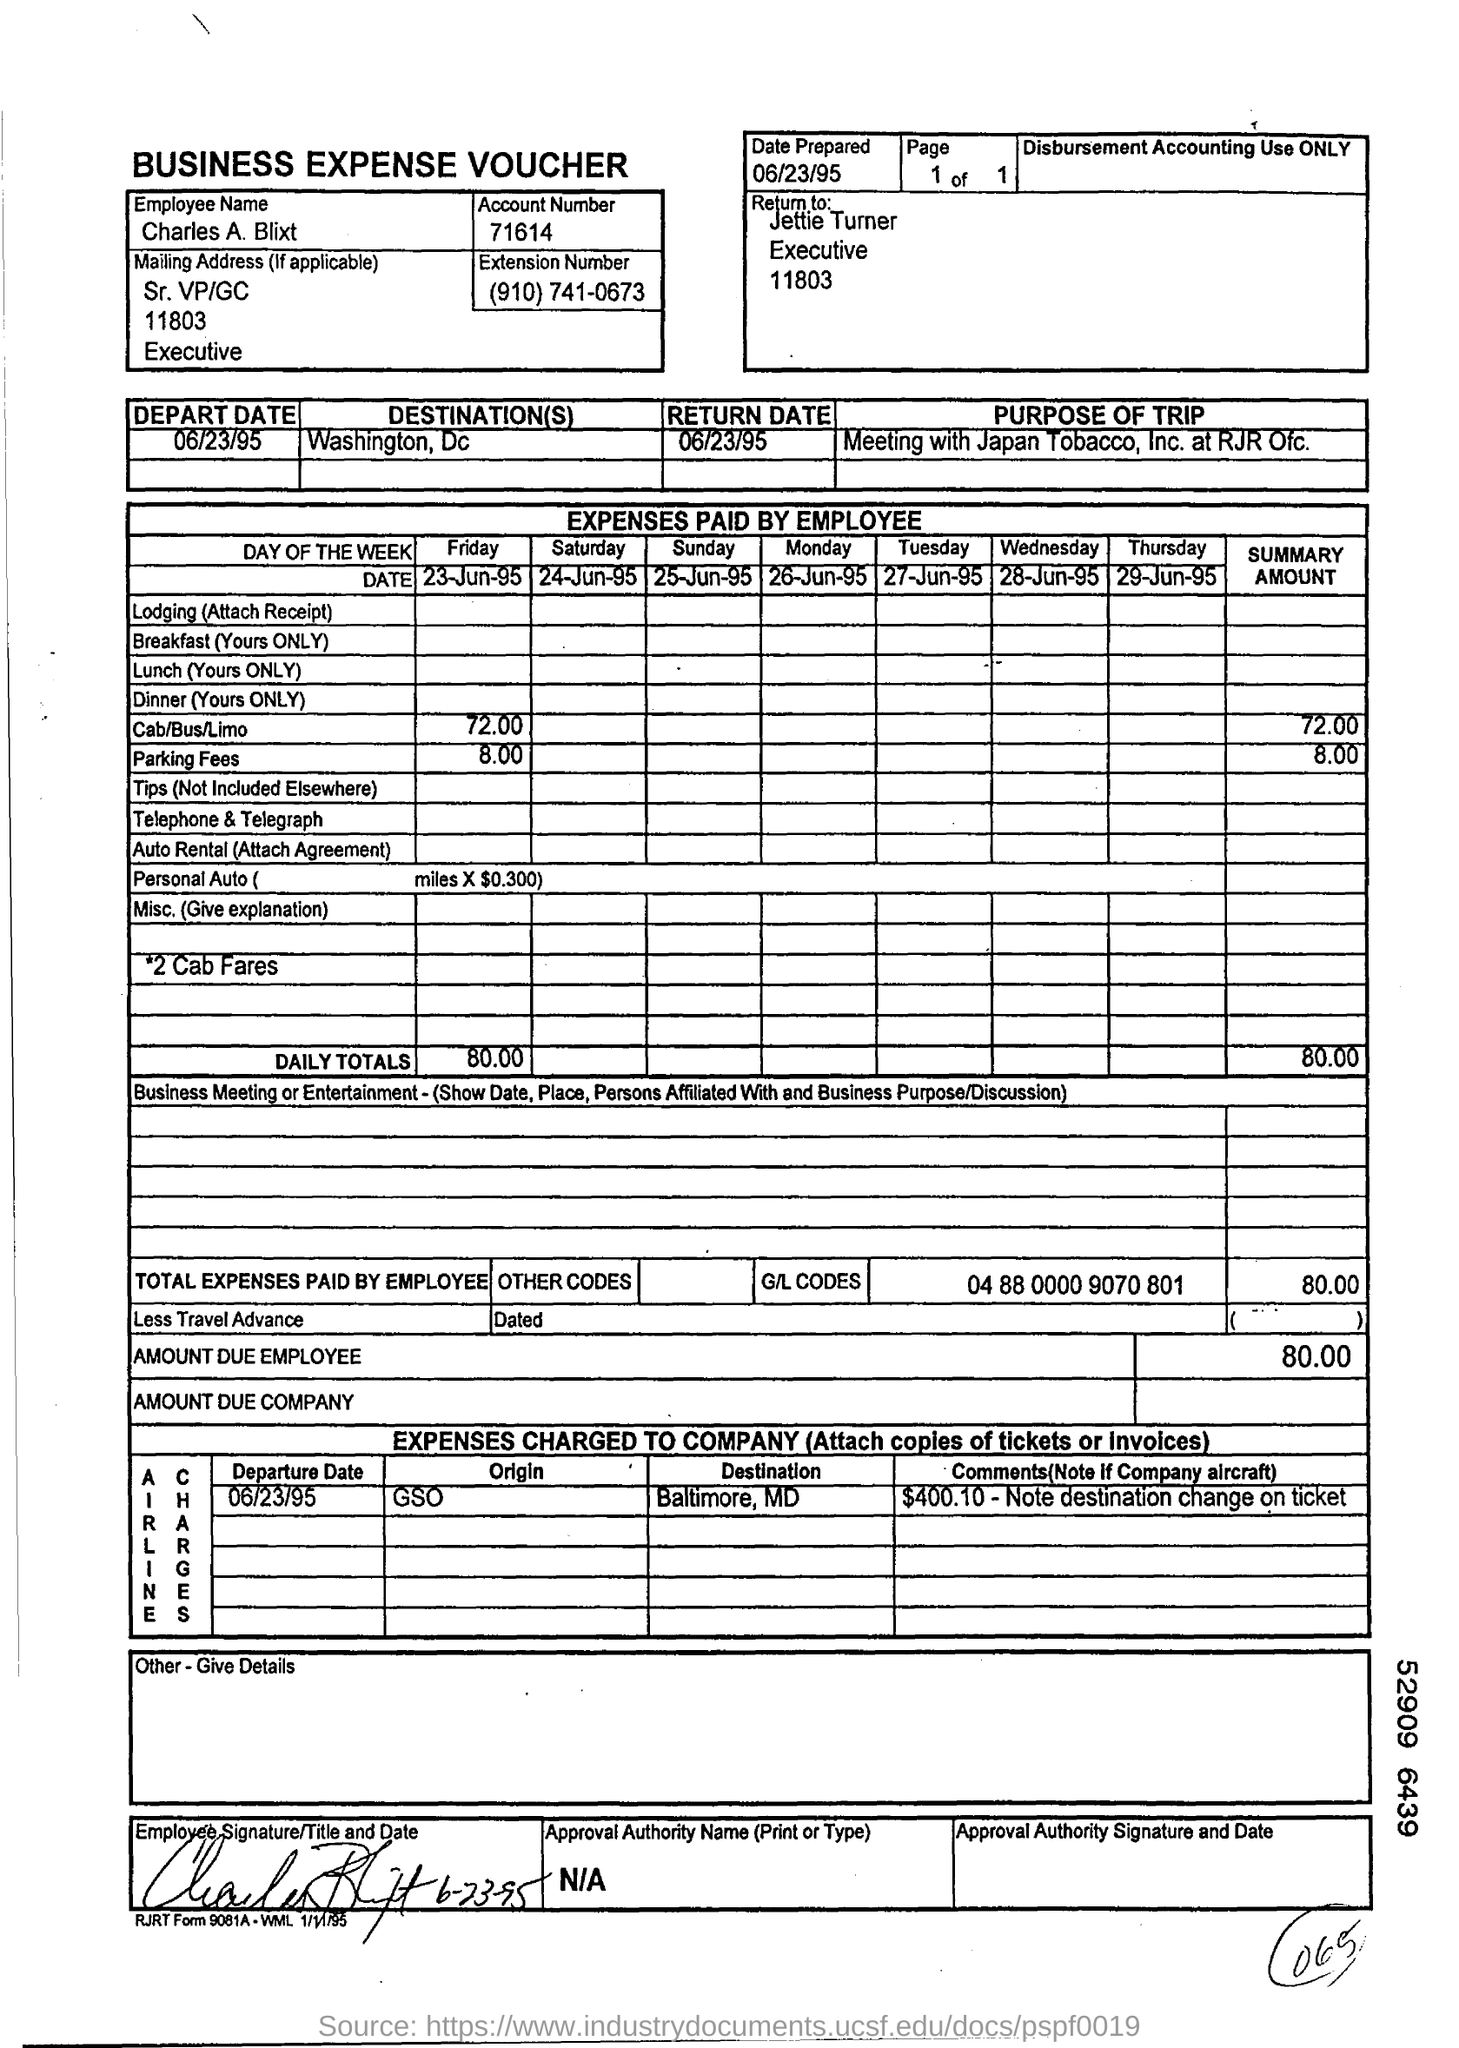List a handful of essential elements in this visual. The departure date is on June 23, 1995. The return date is June 23, 1995. The subject of the sentence is "Who." The predicate is "should it be returned to?" The complement is "Jettie Turner. The summary amount for cab/bus/limo is 72.00. The individual's name is Charles A. Blixt. 